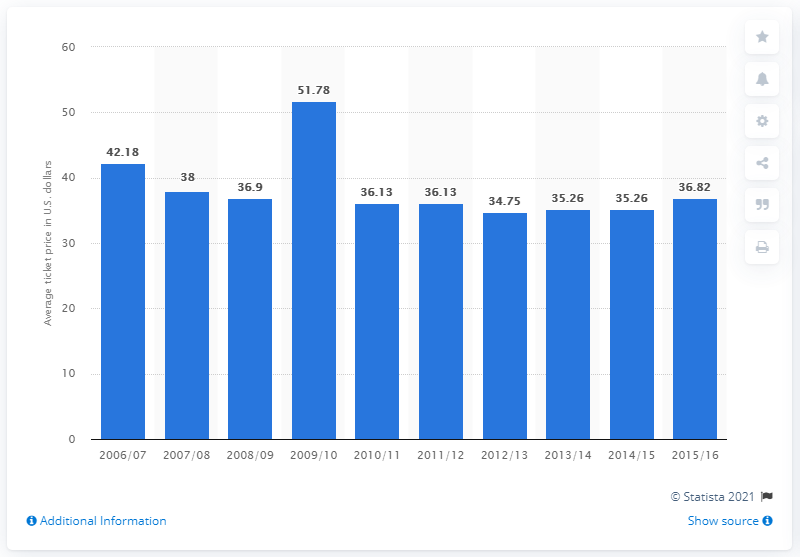Highlight a few significant elements in this photo. The average ticket price for Atlanta Hawks games in the 2006/07 season was 42.18. 